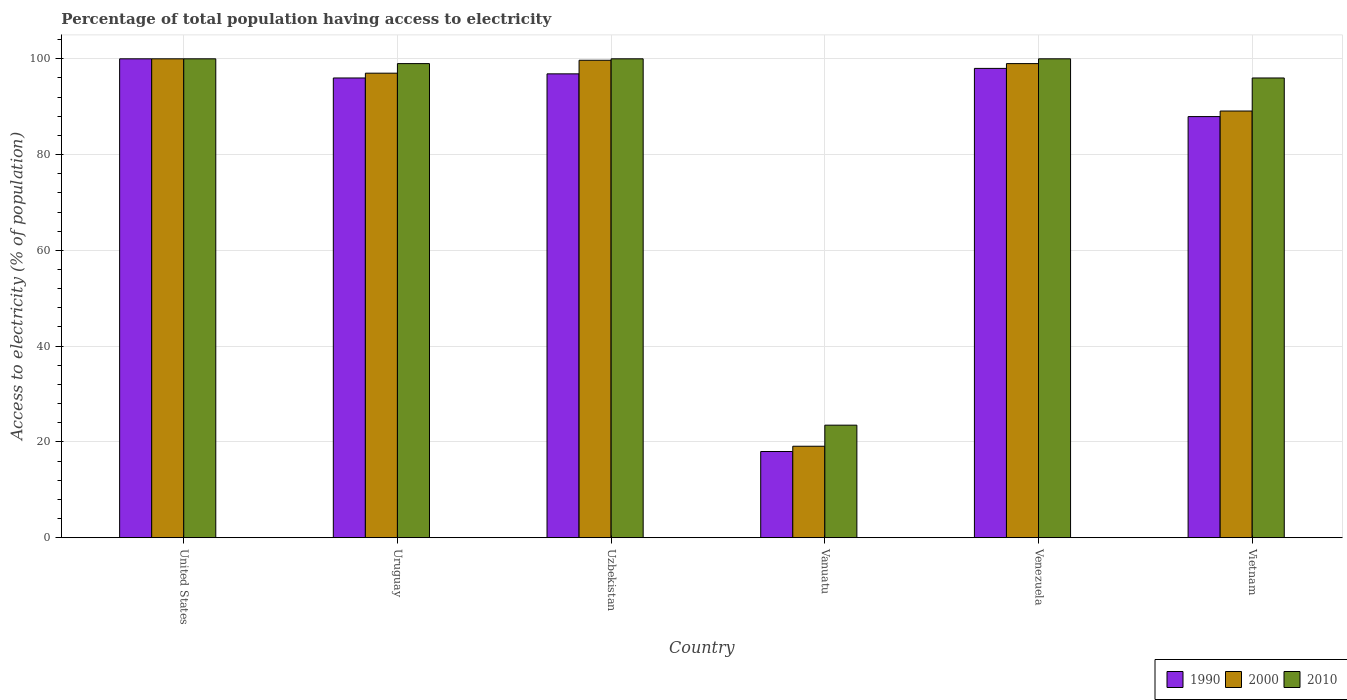How many bars are there on the 1st tick from the left?
Your answer should be compact. 3. What is the label of the 2nd group of bars from the left?
Ensure brevity in your answer.  Uruguay. What is the percentage of population that have access to electricity in 2000 in Uruguay?
Your answer should be very brief. 97. In which country was the percentage of population that have access to electricity in 1990 maximum?
Your answer should be very brief. United States. In which country was the percentage of population that have access to electricity in 1990 minimum?
Provide a succinct answer. Vanuatu. What is the total percentage of population that have access to electricity in 2010 in the graph?
Provide a succinct answer. 518.5. What is the difference between the percentage of population that have access to electricity in 2010 in Uzbekistan and that in Vanuatu?
Keep it short and to the point. 76.5. What is the difference between the percentage of population that have access to electricity in 2010 in Venezuela and the percentage of population that have access to electricity in 1990 in Uruguay?
Give a very brief answer. 4. What is the average percentage of population that have access to electricity in 2010 per country?
Provide a short and direct response. 86.42. What is the ratio of the percentage of population that have access to electricity in 2010 in United States to that in Vietnam?
Ensure brevity in your answer.  1.04. Is the percentage of population that have access to electricity in 2000 in Uzbekistan less than that in Venezuela?
Your response must be concise. No. Is the difference between the percentage of population that have access to electricity in 2010 in Uzbekistan and Venezuela greater than the difference between the percentage of population that have access to electricity in 1990 in Uzbekistan and Venezuela?
Your response must be concise. Yes. What is the difference between the highest and the second highest percentage of population that have access to electricity in 1990?
Your response must be concise. -1.14. What is the difference between the highest and the lowest percentage of population that have access to electricity in 2010?
Make the answer very short. 76.5. What does the 3rd bar from the right in United States represents?
Give a very brief answer. 1990. Is it the case that in every country, the sum of the percentage of population that have access to electricity in 2000 and percentage of population that have access to electricity in 2010 is greater than the percentage of population that have access to electricity in 1990?
Make the answer very short. Yes. How many bars are there?
Your response must be concise. 18. Are all the bars in the graph horizontal?
Provide a short and direct response. No. How many countries are there in the graph?
Keep it short and to the point. 6. Are the values on the major ticks of Y-axis written in scientific E-notation?
Offer a terse response. No. How many legend labels are there?
Make the answer very short. 3. What is the title of the graph?
Give a very brief answer. Percentage of total population having access to electricity. What is the label or title of the X-axis?
Offer a terse response. Country. What is the label or title of the Y-axis?
Offer a very short reply. Access to electricity (% of population). What is the Access to electricity (% of population) in 2000 in United States?
Your answer should be very brief. 100. What is the Access to electricity (% of population) of 2010 in United States?
Give a very brief answer. 100. What is the Access to electricity (% of population) in 1990 in Uruguay?
Keep it short and to the point. 96. What is the Access to electricity (% of population) of 2000 in Uruguay?
Your response must be concise. 97. What is the Access to electricity (% of population) of 1990 in Uzbekistan?
Keep it short and to the point. 96.86. What is the Access to electricity (% of population) of 2000 in Uzbekistan?
Offer a terse response. 99.7. What is the Access to electricity (% of population) of 1990 in Vanuatu?
Give a very brief answer. 18. What is the Access to electricity (% of population) in 2000 in Vanuatu?
Provide a short and direct response. 19.1. What is the Access to electricity (% of population) in 2010 in Vanuatu?
Provide a succinct answer. 23.5. What is the Access to electricity (% of population) in 1990 in Venezuela?
Keep it short and to the point. 98. What is the Access to electricity (% of population) of 1990 in Vietnam?
Your response must be concise. 87.94. What is the Access to electricity (% of population) of 2000 in Vietnam?
Provide a short and direct response. 89.1. What is the Access to electricity (% of population) in 2010 in Vietnam?
Ensure brevity in your answer.  96. Across all countries, what is the maximum Access to electricity (% of population) of 2000?
Ensure brevity in your answer.  100. Across all countries, what is the maximum Access to electricity (% of population) of 2010?
Your response must be concise. 100. Across all countries, what is the minimum Access to electricity (% of population) in 1990?
Make the answer very short. 18. Across all countries, what is the minimum Access to electricity (% of population) in 2000?
Offer a terse response. 19.1. What is the total Access to electricity (% of population) in 1990 in the graph?
Keep it short and to the point. 496.8. What is the total Access to electricity (% of population) of 2000 in the graph?
Keep it short and to the point. 503.9. What is the total Access to electricity (% of population) of 2010 in the graph?
Ensure brevity in your answer.  518.5. What is the difference between the Access to electricity (% of population) of 1990 in United States and that in Uruguay?
Give a very brief answer. 4. What is the difference between the Access to electricity (% of population) of 2000 in United States and that in Uruguay?
Your response must be concise. 3. What is the difference between the Access to electricity (% of population) in 1990 in United States and that in Uzbekistan?
Make the answer very short. 3.14. What is the difference between the Access to electricity (% of population) of 2010 in United States and that in Uzbekistan?
Ensure brevity in your answer.  0. What is the difference between the Access to electricity (% of population) of 1990 in United States and that in Vanuatu?
Offer a very short reply. 82. What is the difference between the Access to electricity (% of population) in 2000 in United States and that in Vanuatu?
Your answer should be very brief. 80.9. What is the difference between the Access to electricity (% of population) of 2010 in United States and that in Vanuatu?
Provide a succinct answer. 76.5. What is the difference between the Access to electricity (% of population) in 1990 in United States and that in Vietnam?
Give a very brief answer. 12.06. What is the difference between the Access to electricity (% of population) in 2010 in United States and that in Vietnam?
Offer a very short reply. 4. What is the difference between the Access to electricity (% of population) in 1990 in Uruguay and that in Uzbekistan?
Offer a very short reply. -0.86. What is the difference between the Access to electricity (% of population) of 1990 in Uruguay and that in Vanuatu?
Provide a short and direct response. 78. What is the difference between the Access to electricity (% of population) of 2000 in Uruguay and that in Vanuatu?
Provide a succinct answer. 77.9. What is the difference between the Access to electricity (% of population) in 2010 in Uruguay and that in Vanuatu?
Provide a short and direct response. 75.5. What is the difference between the Access to electricity (% of population) in 1990 in Uruguay and that in Venezuela?
Your answer should be compact. -2. What is the difference between the Access to electricity (% of population) in 1990 in Uruguay and that in Vietnam?
Your answer should be compact. 8.06. What is the difference between the Access to electricity (% of population) in 2000 in Uruguay and that in Vietnam?
Ensure brevity in your answer.  7.9. What is the difference between the Access to electricity (% of population) in 2010 in Uruguay and that in Vietnam?
Provide a succinct answer. 3. What is the difference between the Access to electricity (% of population) in 1990 in Uzbekistan and that in Vanuatu?
Your answer should be compact. 78.86. What is the difference between the Access to electricity (% of population) in 2000 in Uzbekistan and that in Vanuatu?
Give a very brief answer. 80.6. What is the difference between the Access to electricity (% of population) of 2010 in Uzbekistan and that in Vanuatu?
Make the answer very short. 76.5. What is the difference between the Access to electricity (% of population) of 1990 in Uzbekistan and that in Venezuela?
Your answer should be very brief. -1.14. What is the difference between the Access to electricity (% of population) in 2000 in Uzbekistan and that in Venezuela?
Provide a short and direct response. 0.7. What is the difference between the Access to electricity (% of population) of 1990 in Uzbekistan and that in Vietnam?
Ensure brevity in your answer.  8.92. What is the difference between the Access to electricity (% of population) of 2010 in Uzbekistan and that in Vietnam?
Your response must be concise. 4. What is the difference between the Access to electricity (% of population) of 1990 in Vanuatu and that in Venezuela?
Offer a very short reply. -80. What is the difference between the Access to electricity (% of population) in 2000 in Vanuatu and that in Venezuela?
Your answer should be compact. -79.9. What is the difference between the Access to electricity (% of population) of 2010 in Vanuatu and that in Venezuela?
Your answer should be very brief. -76.5. What is the difference between the Access to electricity (% of population) in 1990 in Vanuatu and that in Vietnam?
Provide a short and direct response. -69.94. What is the difference between the Access to electricity (% of population) in 2000 in Vanuatu and that in Vietnam?
Your answer should be compact. -70. What is the difference between the Access to electricity (% of population) of 2010 in Vanuatu and that in Vietnam?
Your answer should be compact. -72.5. What is the difference between the Access to electricity (% of population) of 1990 in Venezuela and that in Vietnam?
Ensure brevity in your answer.  10.06. What is the difference between the Access to electricity (% of population) in 2000 in Venezuela and that in Vietnam?
Ensure brevity in your answer.  9.9. What is the difference between the Access to electricity (% of population) in 1990 in United States and the Access to electricity (% of population) in 2000 in Uruguay?
Make the answer very short. 3. What is the difference between the Access to electricity (% of population) in 1990 in United States and the Access to electricity (% of population) in 2000 in Uzbekistan?
Your answer should be compact. 0.3. What is the difference between the Access to electricity (% of population) of 1990 in United States and the Access to electricity (% of population) of 2010 in Uzbekistan?
Your response must be concise. 0. What is the difference between the Access to electricity (% of population) of 2000 in United States and the Access to electricity (% of population) of 2010 in Uzbekistan?
Keep it short and to the point. 0. What is the difference between the Access to electricity (% of population) of 1990 in United States and the Access to electricity (% of population) of 2000 in Vanuatu?
Provide a succinct answer. 80.9. What is the difference between the Access to electricity (% of population) in 1990 in United States and the Access to electricity (% of population) in 2010 in Vanuatu?
Your response must be concise. 76.5. What is the difference between the Access to electricity (% of population) of 2000 in United States and the Access to electricity (% of population) of 2010 in Vanuatu?
Provide a succinct answer. 76.5. What is the difference between the Access to electricity (% of population) in 1990 in United States and the Access to electricity (% of population) in 2000 in Venezuela?
Make the answer very short. 1. What is the difference between the Access to electricity (% of population) of 1990 in United States and the Access to electricity (% of population) of 2010 in Venezuela?
Offer a very short reply. 0. What is the difference between the Access to electricity (% of population) of 1990 in United States and the Access to electricity (% of population) of 2000 in Vietnam?
Give a very brief answer. 10.9. What is the difference between the Access to electricity (% of population) of 1990 in United States and the Access to electricity (% of population) of 2010 in Vietnam?
Your response must be concise. 4. What is the difference between the Access to electricity (% of population) of 1990 in Uruguay and the Access to electricity (% of population) of 2010 in Uzbekistan?
Your response must be concise. -4. What is the difference between the Access to electricity (% of population) in 1990 in Uruguay and the Access to electricity (% of population) in 2000 in Vanuatu?
Make the answer very short. 76.9. What is the difference between the Access to electricity (% of population) of 1990 in Uruguay and the Access to electricity (% of population) of 2010 in Vanuatu?
Keep it short and to the point. 72.5. What is the difference between the Access to electricity (% of population) in 2000 in Uruguay and the Access to electricity (% of population) in 2010 in Vanuatu?
Make the answer very short. 73.5. What is the difference between the Access to electricity (% of population) in 1990 in Uruguay and the Access to electricity (% of population) in 2000 in Venezuela?
Make the answer very short. -3. What is the difference between the Access to electricity (% of population) in 1990 in Uruguay and the Access to electricity (% of population) in 2010 in Venezuela?
Offer a terse response. -4. What is the difference between the Access to electricity (% of population) in 2000 in Uruguay and the Access to electricity (% of population) in 2010 in Vietnam?
Give a very brief answer. 1. What is the difference between the Access to electricity (% of population) of 1990 in Uzbekistan and the Access to electricity (% of population) of 2000 in Vanuatu?
Provide a short and direct response. 77.76. What is the difference between the Access to electricity (% of population) in 1990 in Uzbekistan and the Access to electricity (% of population) in 2010 in Vanuatu?
Your response must be concise. 73.36. What is the difference between the Access to electricity (% of population) in 2000 in Uzbekistan and the Access to electricity (% of population) in 2010 in Vanuatu?
Your answer should be compact. 76.2. What is the difference between the Access to electricity (% of population) of 1990 in Uzbekistan and the Access to electricity (% of population) of 2000 in Venezuela?
Your answer should be compact. -2.14. What is the difference between the Access to electricity (% of population) in 1990 in Uzbekistan and the Access to electricity (% of population) in 2010 in Venezuela?
Provide a succinct answer. -3.14. What is the difference between the Access to electricity (% of population) in 2000 in Uzbekistan and the Access to electricity (% of population) in 2010 in Venezuela?
Offer a very short reply. -0.3. What is the difference between the Access to electricity (% of population) of 1990 in Uzbekistan and the Access to electricity (% of population) of 2000 in Vietnam?
Ensure brevity in your answer.  7.76. What is the difference between the Access to electricity (% of population) in 1990 in Uzbekistan and the Access to electricity (% of population) in 2010 in Vietnam?
Give a very brief answer. 0.86. What is the difference between the Access to electricity (% of population) in 1990 in Vanuatu and the Access to electricity (% of population) in 2000 in Venezuela?
Make the answer very short. -81. What is the difference between the Access to electricity (% of population) of 1990 in Vanuatu and the Access to electricity (% of population) of 2010 in Venezuela?
Your answer should be very brief. -82. What is the difference between the Access to electricity (% of population) in 2000 in Vanuatu and the Access to electricity (% of population) in 2010 in Venezuela?
Give a very brief answer. -80.9. What is the difference between the Access to electricity (% of population) of 1990 in Vanuatu and the Access to electricity (% of population) of 2000 in Vietnam?
Your answer should be compact. -71.1. What is the difference between the Access to electricity (% of population) of 1990 in Vanuatu and the Access to electricity (% of population) of 2010 in Vietnam?
Make the answer very short. -78. What is the difference between the Access to electricity (% of population) of 2000 in Vanuatu and the Access to electricity (% of population) of 2010 in Vietnam?
Offer a terse response. -76.9. What is the difference between the Access to electricity (% of population) in 1990 in Venezuela and the Access to electricity (% of population) in 2000 in Vietnam?
Offer a terse response. 8.9. What is the average Access to electricity (% of population) of 1990 per country?
Provide a succinct answer. 82.8. What is the average Access to electricity (% of population) in 2000 per country?
Provide a succinct answer. 83.98. What is the average Access to electricity (% of population) in 2010 per country?
Your answer should be compact. 86.42. What is the difference between the Access to electricity (% of population) in 1990 and Access to electricity (% of population) in 2000 in United States?
Offer a terse response. 0. What is the difference between the Access to electricity (% of population) in 1990 and Access to electricity (% of population) in 2010 in United States?
Make the answer very short. 0. What is the difference between the Access to electricity (% of population) of 2000 and Access to electricity (% of population) of 2010 in Uruguay?
Ensure brevity in your answer.  -2. What is the difference between the Access to electricity (% of population) in 1990 and Access to electricity (% of population) in 2000 in Uzbekistan?
Offer a very short reply. -2.84. What is the difference between the Access to electricity (% of population) in 1990 and Access to electricity (% of population) in 2010 in Uzbekistan?
Ensure brevity in your answer.  -3.14. What is the difference between the Access to electricity (% of population) of 2000 and Access to electricity (% of population) of 2010 in Uzbekistan?
Provide a succinct answer. -0.3. What is the difference between the Access to electricity (% of population) of 1990 and Access to electricity (% of population) of 2000 in Vanuatu?
Your response must be concise. -1.1. What is the difference between the Access to electricity (% of population) in 1990 and Access to electricity (% of population) in 2010 in Vanuatu?
Offer a very short reply. -5.5. What is the difference between the Access to electricity (% of population) in 1990 and Access to electricity (% of population) in 2000 in Venezuela?
Your answer should be compact. -1. What is the difference between the Access to electricity (% of population) of 1990 and Access to electricity (% of population) of 2000 in Vietnam?
Your answer should be very brief. -1.16. What is the difference between the Access to electricity (% of population) of 1990 and Access to electricity (% of population) of 2010 in Vietnam?
Keep it short and to the point. -8.06. What is the ratio of the Access to electricity (% of population) of 1990 in United States to that in Uruguay?
Ensure brevity in your answer.  1.04. What is the ratio of the Access to electricity (% of population) in 2000 in United States to that in Uruguay?
Give a very brief answer. 1.03. What is the ratio of the Access to electricity (% of population) of 1990 in United States to that in Uzbekistan?
Give a very brief answer. 1.03. What is the ratio of the Access to electricity (% of population) in 2000 in United States to that in Uzbekistan?
Your answer should be very brief. 1. What is the ratio of the Access to electricity (% of population) in 2010 in United States to that in Uzbekistan?
Offer a terse response. 1. What is the ratio of the Access to electricity (% of population) of 1990 in United States to that in Vanuatu?
Provide a short and direct response. 5.56. What is the ratio of the Access to electricity (% of population) of 2000 in United States to that in Vanuatu?
Make the answer very short. 5.24. What is the ratio of the Access to electricity (% of population) in 2010 in United States to that in Vanuatu?
Ensure brevity in your answer.  4.26. What is the ratio of the Access to electricity (% of population) of 1990 in United States to that in Venezuela?
Provide a short and direct response. 1.02. What is the ratio of the Access to electricity (% of population) in 2010 in United States to that in Venezuela?
Provide a succinct answer. 1. What is the ratio of the Access to electricity (% of population) of 1990 in United States to that in Vietnam?
Offer a very short reply. 1.14. What is the ratio of the Access to electricity (% of population) in 2000 in United States to that in Vietnam?
Give a very brief answer. 1.12. What is the ratio of the Access to electricity (% of population) of 2010 in United States to that in Vietnam?
Provide a succinct answer. 1.04. What is the ratio of the Access to electricity (% of population) in 2000 in Uruguay to that in Uzbekistan?
Keep it short and to the point. 0.97. What is the ratio of the Access to electricity (% of population) of 1990 in Uruguay to that in Vanuatu?
Give a very brief answer. 5.33. What is the ratio of the Access to electricity (% of population) in 2000 in Uruguay to that in Vanuatu?
Provide a short and direct response. 5.08. What is the ratio of the Access to electricity (% of population) in 2010 in Uruguay to that in Vanuatu?
Make the answer very short. 4.21. What is the ratio of the Access to electricity (% of population) in 1990 in Uruguay to that in Venezuela?
Provide a succinct answer. 0.98. What is the ratio of the Access to electricity (% of population) in 2000 in Uruguay to that in Venezuela?
Your answer should be compact. 0.98. What is the ratio of the Access to electricity (% of population) in 1990 in Uruguay to that in Vietnam?
Your response must be concise. 1.09. What is the ratio of the Access to electricity (% of population) in 2000 in Uruguay to that in Vietnam?
Provide a short and direct response. 1.09. What is the ratio of the Access to electricity (% of population) of 2010 in Uruguay to that in Vietnam?
Your answer should be very brief. 1.03. What is the ratio of the Access to electricity (% of population) of 1990 in Uzbekistan to that in Vanuatu?
Offer a terse response. 5.38. What is the ratio of the Access to electricity (% of population) in 2000 in Uzbekistan to that in Vanuatu?
Your answer should be very brief. 5.22. What is the ratio of the Access to electricity (% of population) of 2010 in Uzbekistan to that in Vanuatu?
Make the answer very short. 4.26. What is the ratio of the Access to electricity (% of population) in 1990 in Uzbekistan to that in Venezuela?
Offer a very short reply. 0.99. What is the ratio of the Access to electricity (% of population) of 2000 in Uzbekistan to that in Venezuela?
Your answer should be compact. 1.01. What is the ratio of the Access to electricity (% of population) in 1990 in Uzbekistan to that in Vietnam?
Give a very brief answer. 1.1. What is the ratio of the Access to electricity (% of population) in 2000 in Uzbekistan to that in Vietnam?
Your answer should be compact. 1.12. What is the ratio of the Access to electricity (% of population) of 2010 in Uzbekistan to that in Vietnam?
Give a very brief answer. 1.04. What is the ratio of the Access to electricity (% of population) of 1990 in Vanuatu to that in Venezuela?
Your answer should be compact. 0.18. What is the ratio of the Access to electricity (% of population) of 2000 in Vanuatu to that in Venezuela?
Your answer should be compact. 0.19. What is the ratio of the Access to electricity (% of population) of 2010 in Vanuatu to that in Venezuela?
Provide a succinct answer. 0.23. What is the ratio of the Access to electricity (% of population) in 1990 in Vanuatu to that in Vietnam?
Your answer should be very brief. 0.2. What is the ratio of the Access to electricity (% of population) in 2000 in Vanuatu to that in Vietnam?
Provide a short and direct response. 0.21. What is the ratio of the Access to electricity (% of population) of 2010 in Vanuatu to that in Vietnam?
Give a very brief answer. 0.24. What is the ratio of the Access to electricity (% of population) in 1990 in Venezuela to that in Vietnam?
Ensure brevity in your answer.  1.11. What is the ratio of the Access to electricity (% of population) in 2010 in Venezuela to that in Vietnam?
Offer a terse response. 1.04. What is the difference between the highest and the second highest Access to electricity (% of population) of 2010?
Give a very brief answer. 0. What is the difference between the highest and the lowest Access to electricity (% of population) in 2000?
Keep it short and to the point. 80.9. What is the difference between the highest and the lowest Access to electricity (% of population) in 2010?
Your answer should be compact. 76.5. 